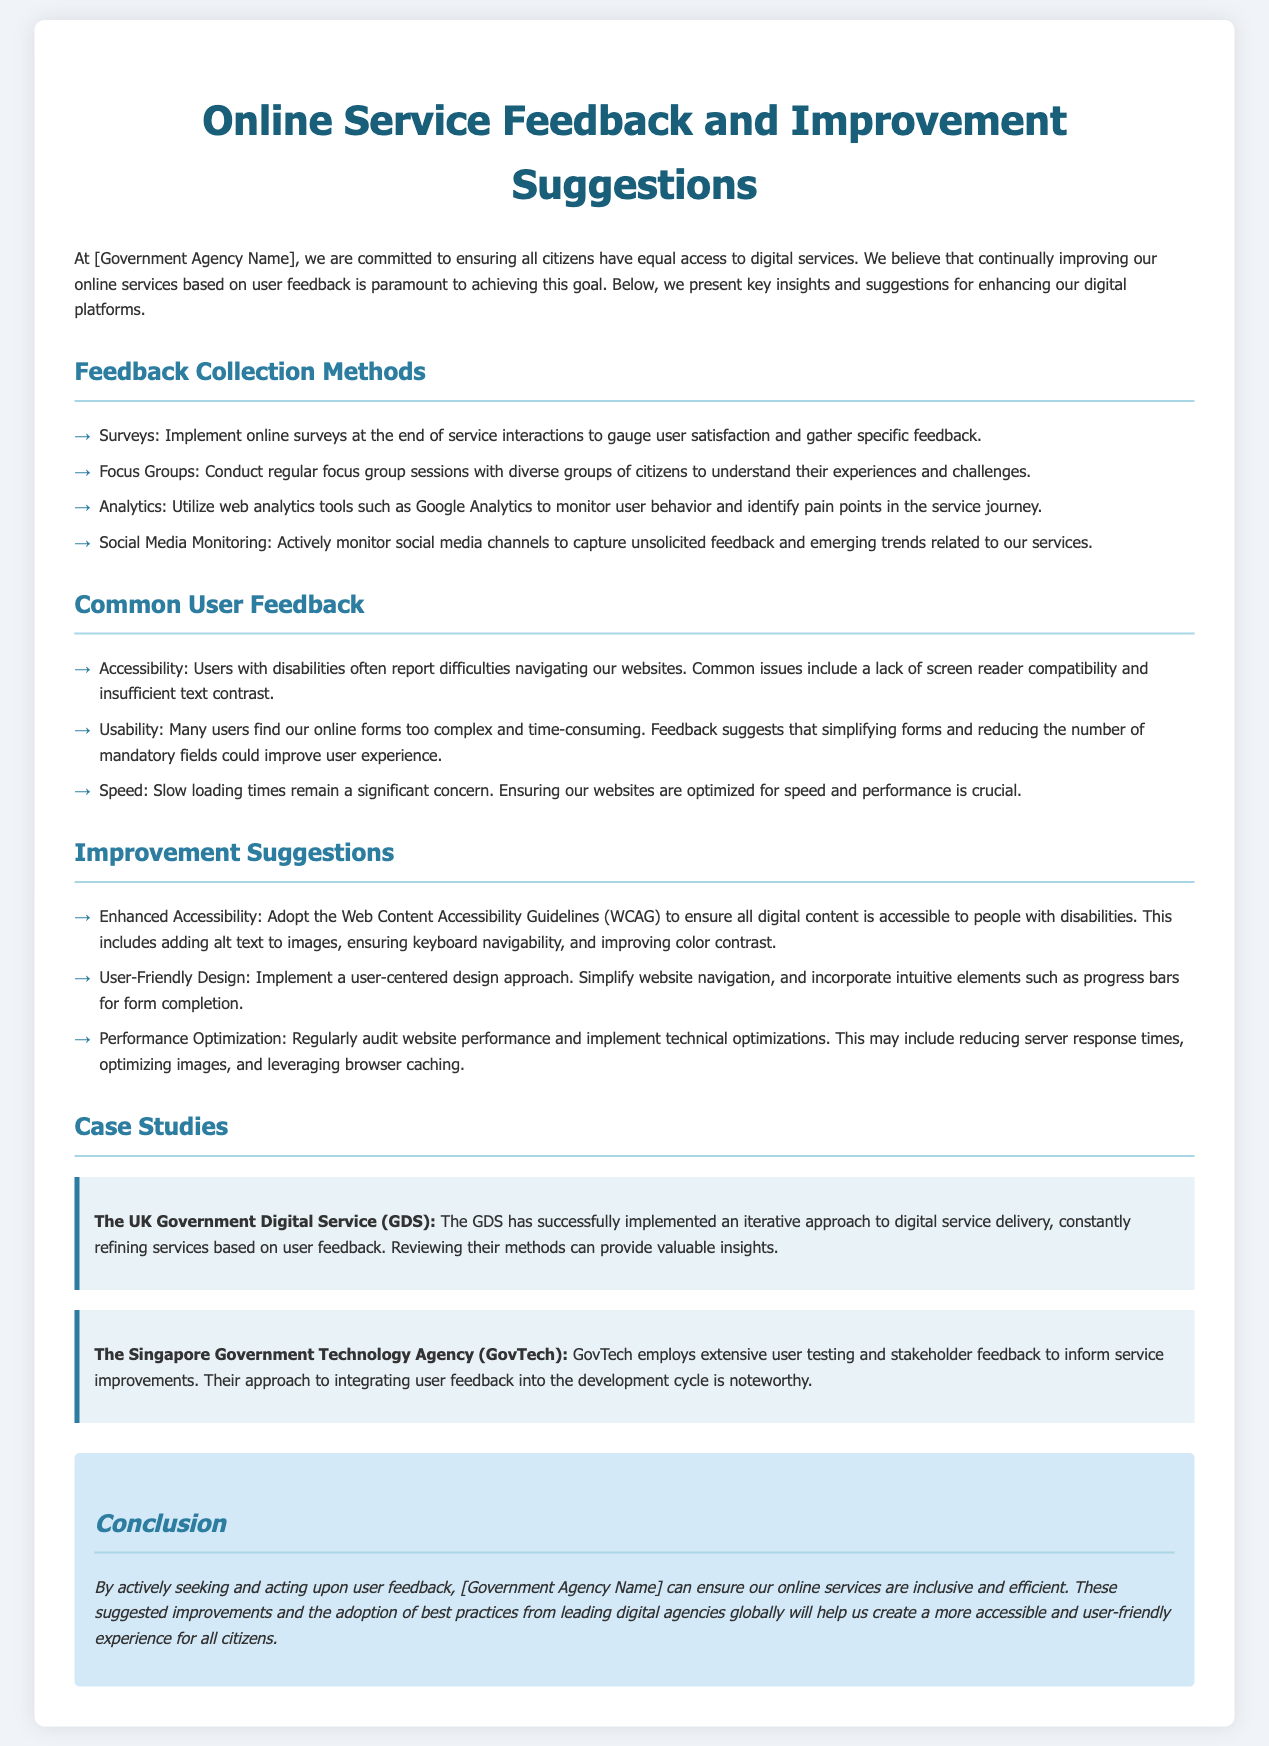What are the feedback collection methods mentioned? The document lists various methods used for collecting feedback, including surveys, focus groups, analytics, and social media monitoring.
Answer: Surveys, focus groups, analytics, social media monitoring What is the primary goal of feedback collection in the document? The document emphasizes that the main goal of collecting feedback is to continually improve online services based on user feedback to ensure equal access for all citizens.
Answer: Equal access to digital services What is one common user feedback regarding accessibility? The document notes that users with disabilities report difficulties navigating websites, particularly citing a lack of screen reader compatibility and insufficient text contrast.
Answer: Lack of screen reader compatibility What are the suggested improvement suggestions related to design? The document proposes implementing a user-centered design approach that simplifies website navigation and incorporates intuitive elements like progress bars for form completion.
Answer: User-centered design approach Who is the case study about the UK Government Digital Service? The case study highlights the iterative approach of the UK Government Digital Service (GDS) in refining services based on user feedback, which could provide valuable insights.
Answer: The UK Government Digital Service (GDS) How does the document define the conclusion regarding user feedback? The conclusion states that actively seeking and acting upon user feedback is essential for ensuring online services are inclusive and efficient, also highlighting the adoption of best practices globally.
Answer: Inclusive and efficient online services What usability issue do many users find with online forms? Users report that many online forms are too complex and time-consuming, suggesting that simplifying forms and reducing mandatory fields could enhance the user experience.
Answer: Complex and time-consuming forms What technical suggestions are made for website performance? The document advises regularly auditing website performance, reducing server response times, optimizing images, and leveraging browser caching as part of performance optimization.
Answer: Regularly audit website performance 